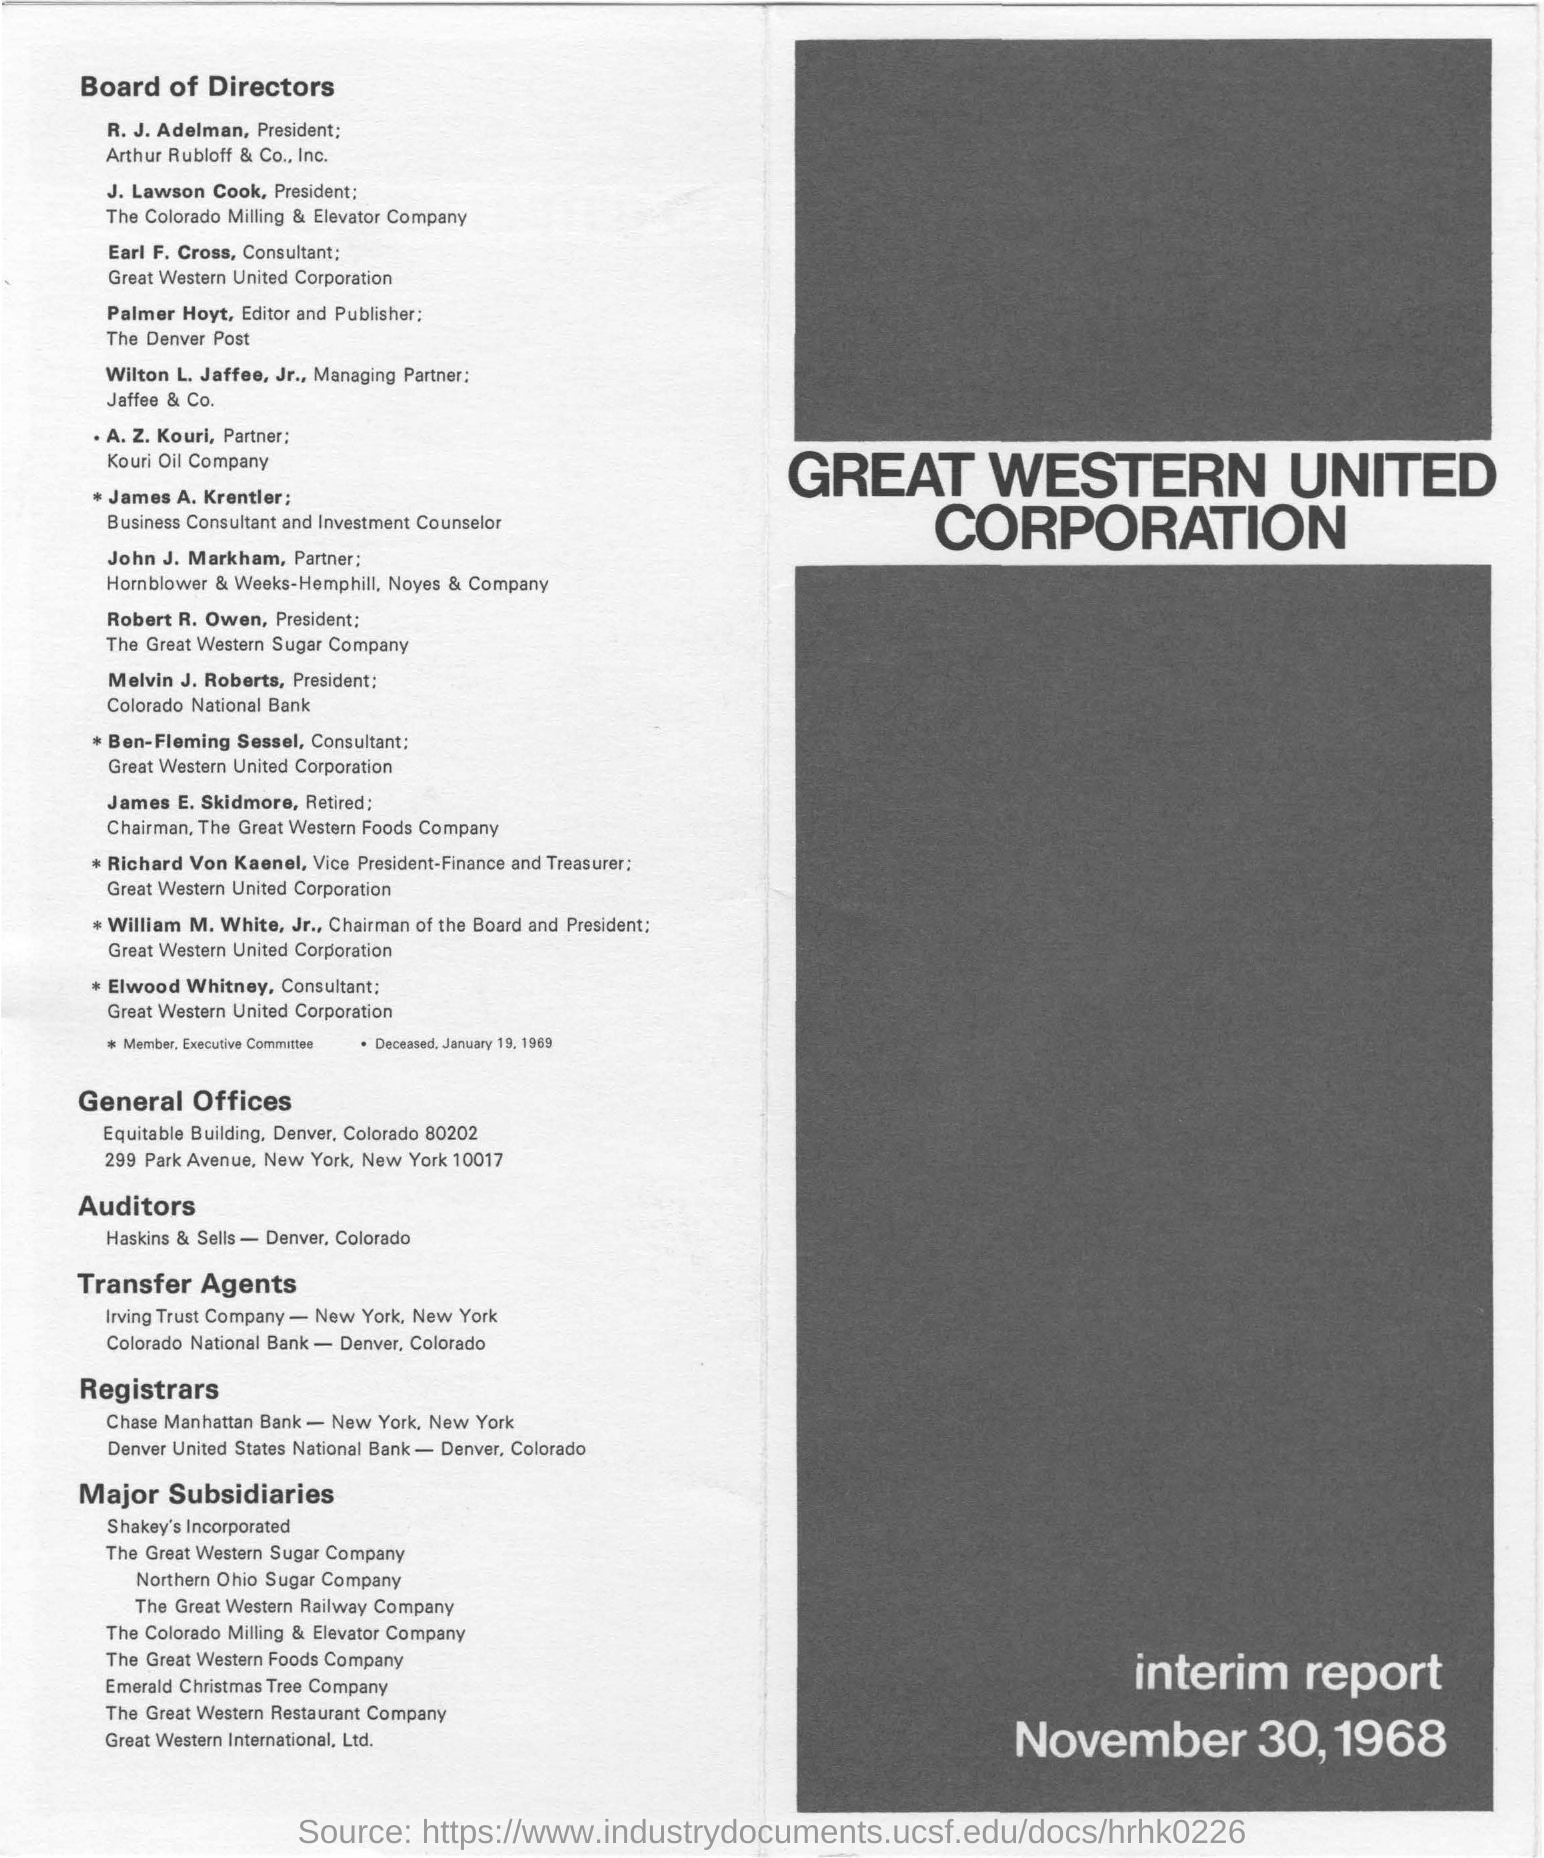Who is the  president of Colorado milling and elevator company?
Your answer should be very brief. J. Lawson Cook. Who is the consultant of great Western United corporation?
Your answer should be compact. Earl F. Cross. Who is the partner of kouri oil company?
Provide a succinct answer. A. Z. Kouri. Who is the president of Colorado national bank?
Your response must be concise. Melvin J. Roberts. 